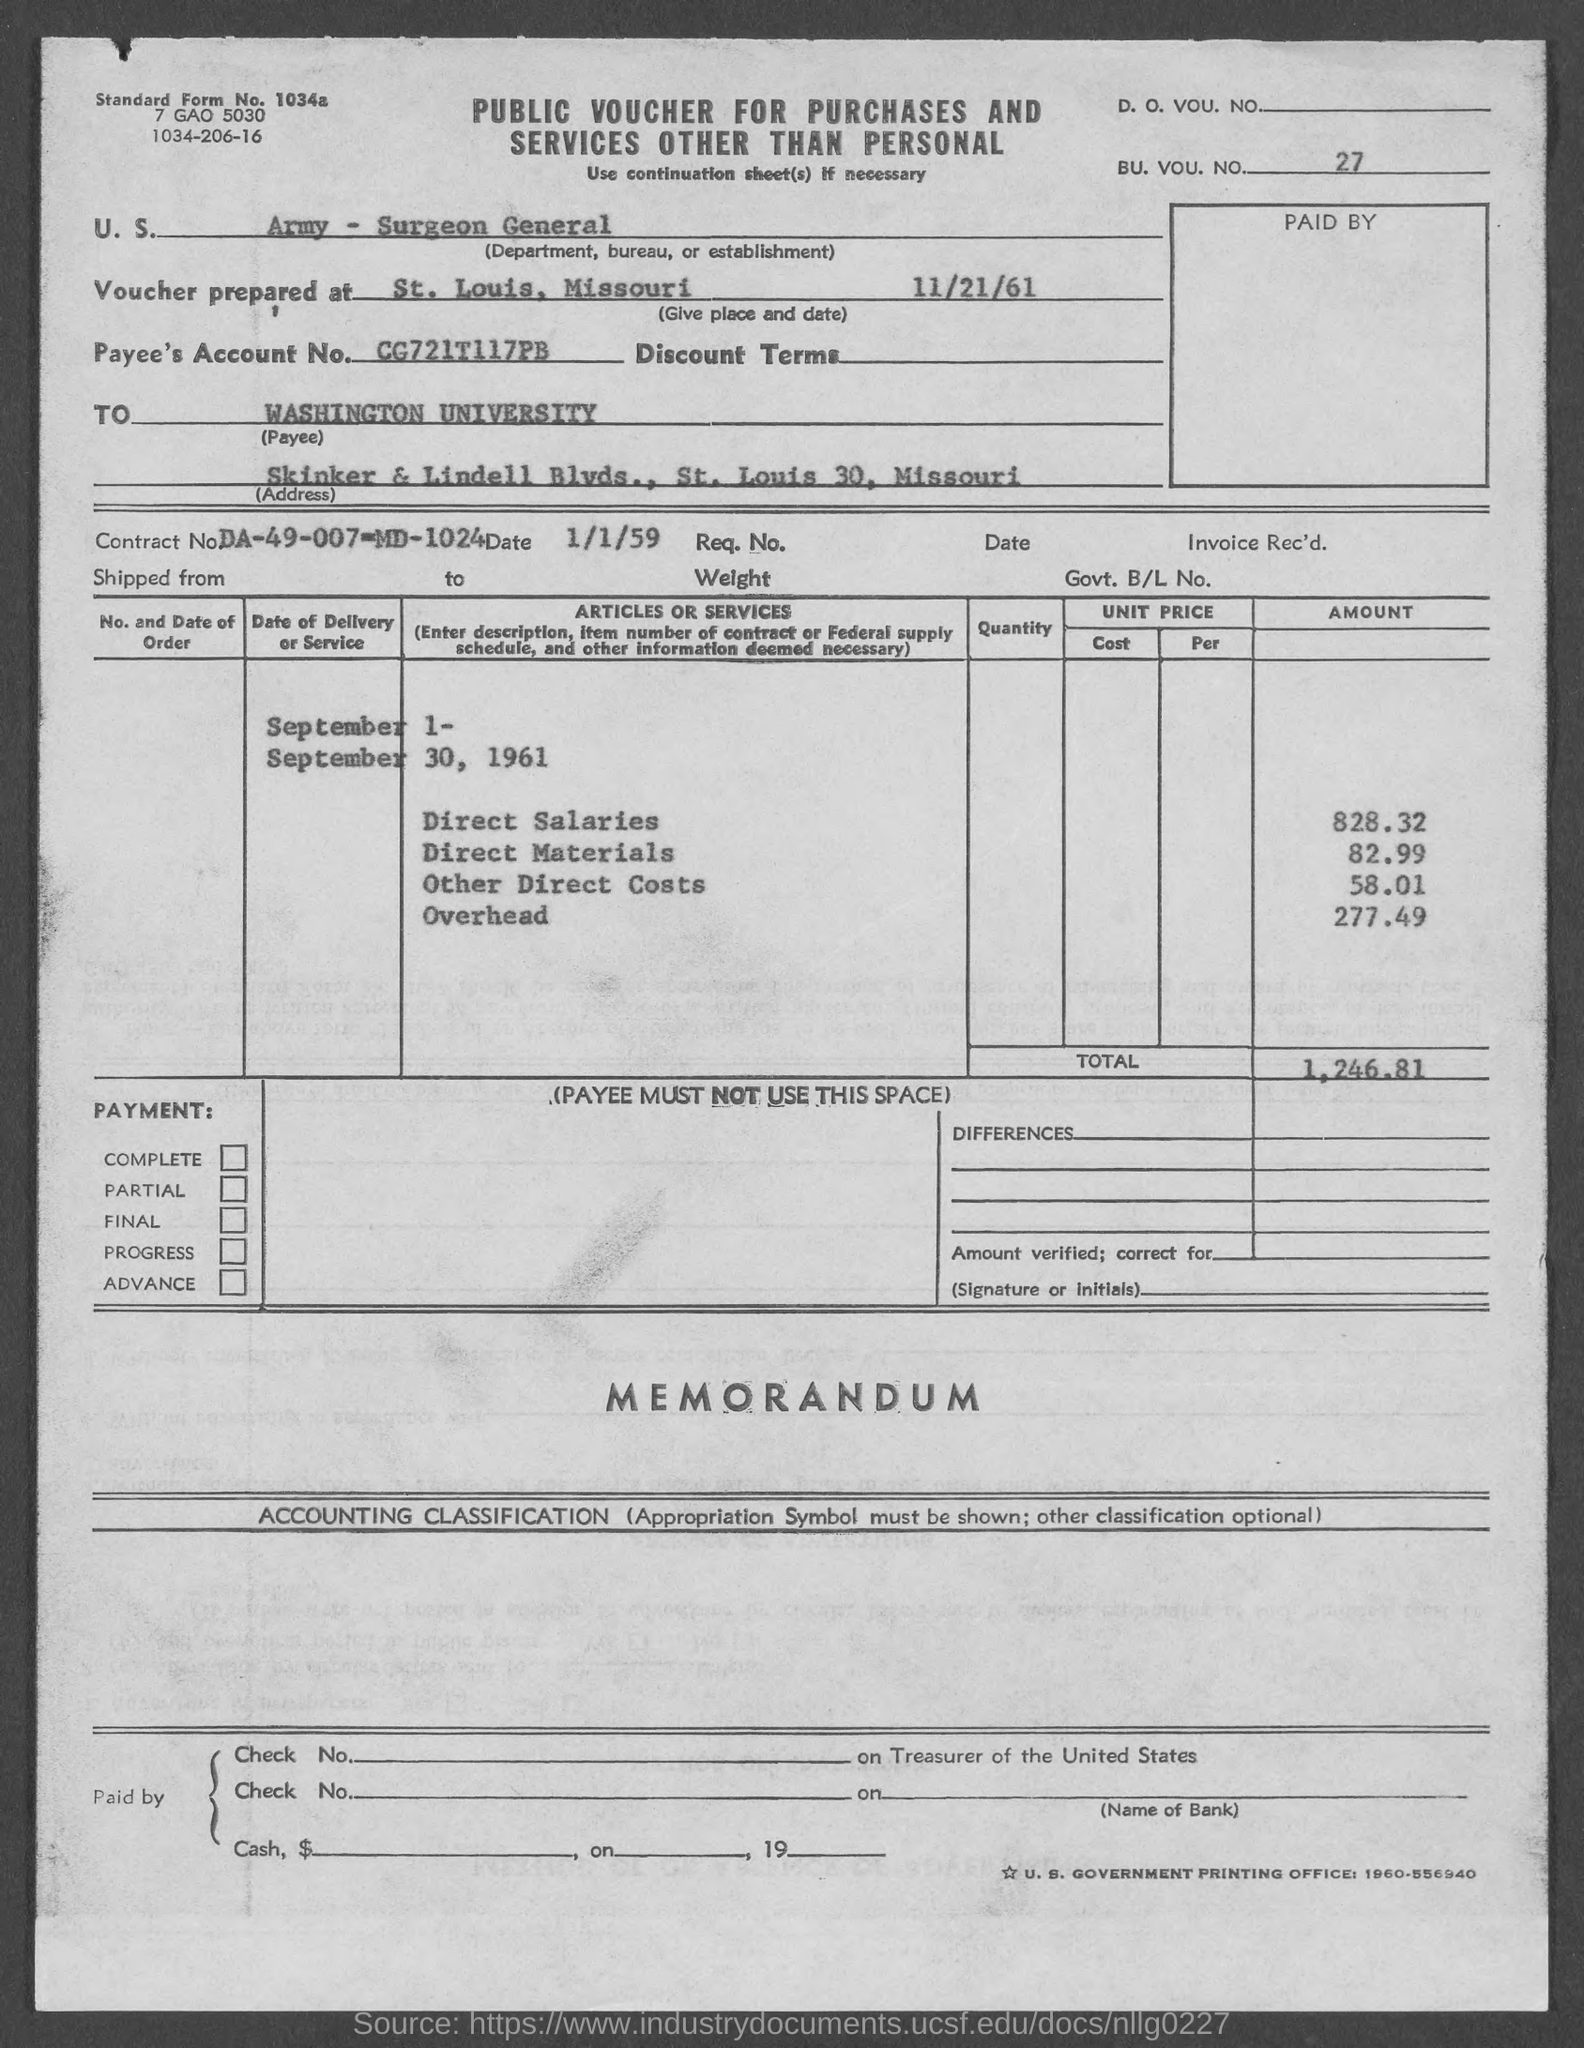What is the bu. vou. no.?
Offer a terse response. 27. What is the standard form no.?
Ensure brevity in your answer.  1034a. What is the payee's account no.?
Ensure brevity in your answer.  Cg721t117pb. What is the contract no.?
Give a very brief answer. Da-49-007-md-1024. What is the total ?
Your answer should be compact. 1,246.81. What is the amount of direct salaries ?
Your answer should be compact. 828.32. What is the amount of direct materials ?
Offer a terse response. 82.99. What is the amount of other direct costs?
Your response must be concise. 58.01. What is the amount of overhead?
Your answer should be very brief. 277.49. In which state is washington university located ?
Ensure brevity in your answer.  Missouri. 